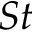<formula> <loc_0><loc_0><loc_500><loc_500>S t</formula> 